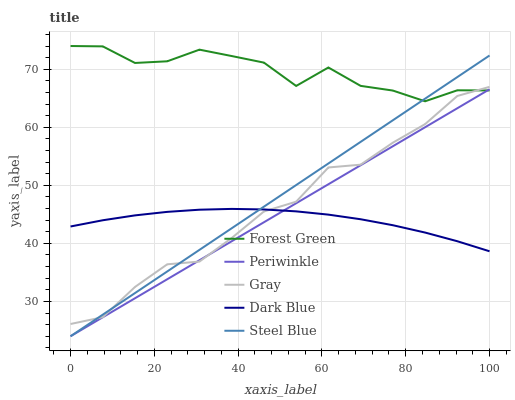Does Dark Blue have the minimum area under the curve?
Answer yes or no. Yes. Does Forest Green have the maximum area under the curve?
Answer yes or no. Yes. Does Periwinkle have the minimum area under the curve?
Answer yes or no. No. Does Periwinkle have the maximum area under the curve?
Answer yes or no. No. Is Periwinkle the smoothest?
Answer yes or no. Yes. Is Forest Green the roughest?
Answer yes or no. Yes. Is Forest Green the smoothest?
Answer yes or no. No. Is Periwinkle the roughest?
Answer yes or no. No. Does Forest Green have the lowest value?
Answer yes or no. No. Does Forest Green have the highest value?
Answer yes or no. Yes. Does Periwinkle have the highest value?
Answer yes or no. No. Is Dark Blue less than Forest Green?
Answer yes or no. Yes. Is Forest Green greater than Dark Blue?
Answer yes or no. Yes. Does Dark Blue intersect Forest Green?
Answer yes or no. No. 